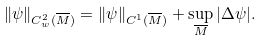<formula> <loc_0><loc_0><loc_500><loc_500>\| \psi \| _ { C ^ { 2 } _ { w } ( \overline { M } ) } = \| \psi \| _ { C ^ { 1 } ( \overline { M } ) } + \sup _ { \overline { M } } | \Delta \psi | .</formula> 